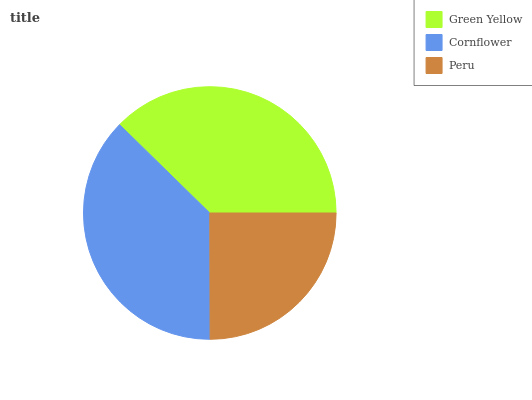Is Peru the minimum?
Answer yes or no. Yes. Is Green Yellow the maximum?
Answer yes or no. Yes. Is Cornflower the minimum?
Answer yes or no. No. Is Cornflower the maximum?
Answer yes or no. No. Is Green Yellow greater than Cornflower?
Answer yes or no. Yes. Is Cornflower less than Green Yellow?
Answer yes or no. Yes. Is Cornflower greater than Green Yellow?
Answer yes or no. No. Is Green Yellow less than Cornflower?
Answer yes or no. No. Is Cornflower the high median?
Answer yes or no. Yes. Is Cornflower the low median?
Answer yes or no. Yes. Is Green Yellow the high median?
Answer yes or no. No. Is Green Yellow the low median?
Answer yes or no. No. 